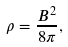Convert formula to latex. <formula><loc_0><loc_0><loc_500><loc_500>\rho = \frac { B ^ { 2 } } { 8 \pi } ,</formula> 